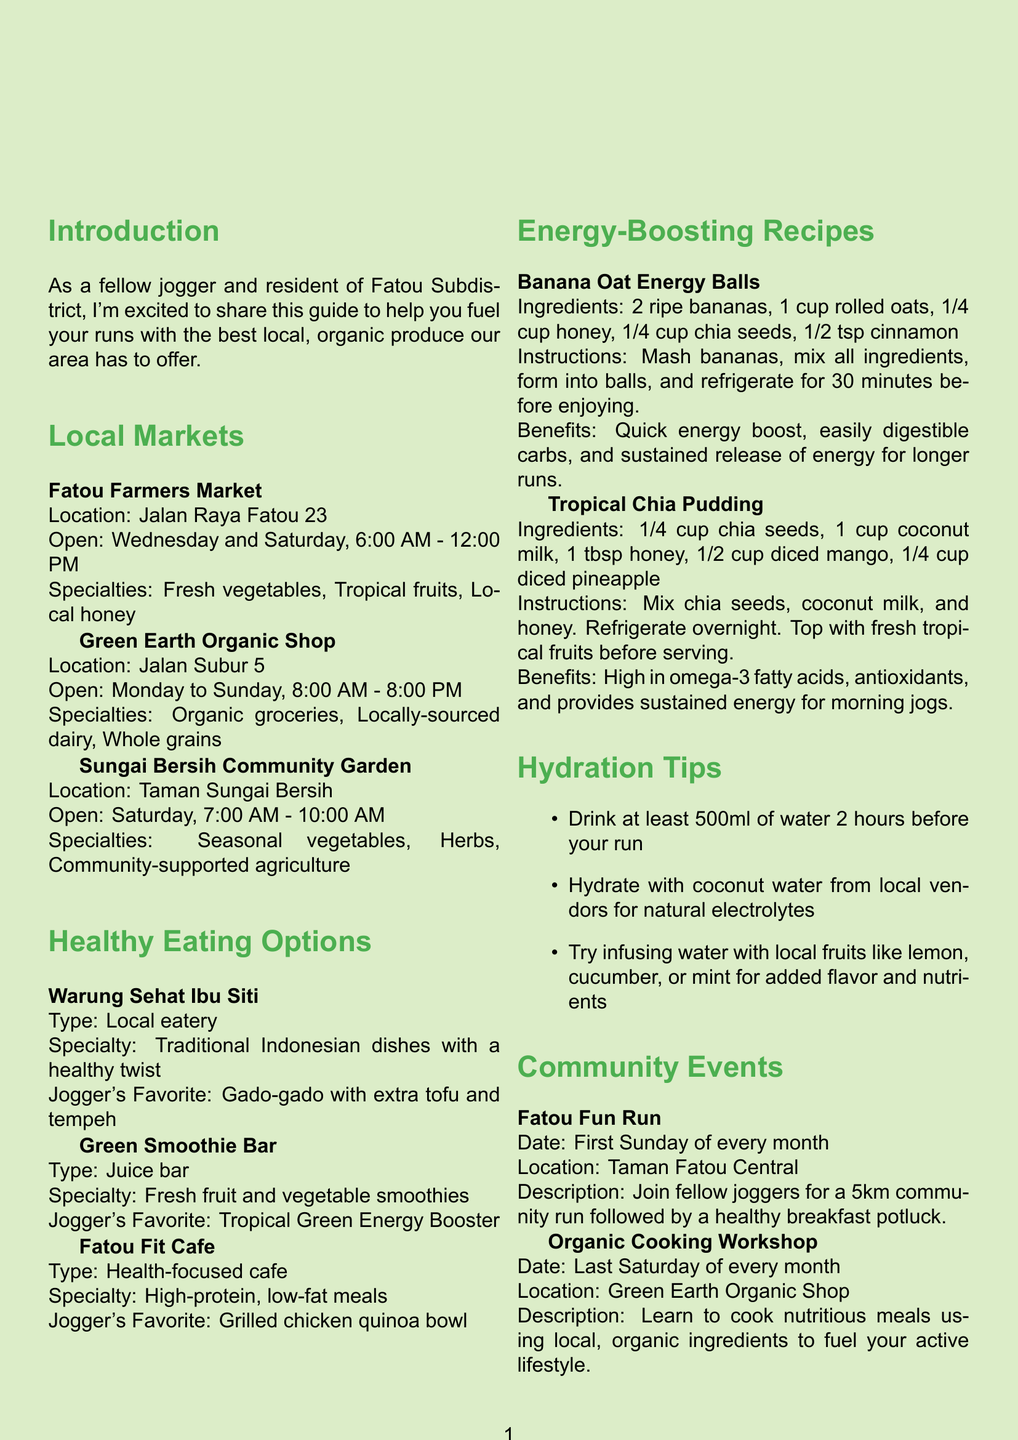What are the opening days of Fatou Farmers Market? The document lists the opening days of Fatou Farmers Market as Wednesday and Saturday.
Answer: Wednesday and Saturday What is the specialty of Green Smoothie Bar? The document states that the specialty of Green Smoothie Bar is fresh fruit and vegetable smoothies.
Answer: Fresh fruit and vegetable smoothies What benefits do Banana Oat Energy Balls provide? The document mentions that Banana Oat Energy Balls provide a quick energy boost, easily digestible carbs, and sustained release of energy for longer runs.
Answer: Quick energy boost How many community events are listed in the brochure? The document enumerates two community events: Fatou Fun Run and Organic Cooking Workshop.
Answer: Two What type of meals does Fatou Fit Cafe serve? The document specifies that Fatou Fit Cafe serves high-protein, low-fat meals.
Answer: High-protein, low-fat meals What is the address of Green Earth Organic Shop? The document provides the location of Green Earth Organic Shop as Jalan Subur 5.
Answer: Jalan Subur 5 When is the Fatou Fun Run held? According to the document, the Fatou Fun Run is held on the first Sunday of every month.
Answer: First Sunday of every month What is one of the hydration tips given in the brochure? The document includes multiple hydration tips; one is to drink at least 500ml of water 2 hours before your run.
Answer: Drink at least 500ml of water 2 hours before your run 